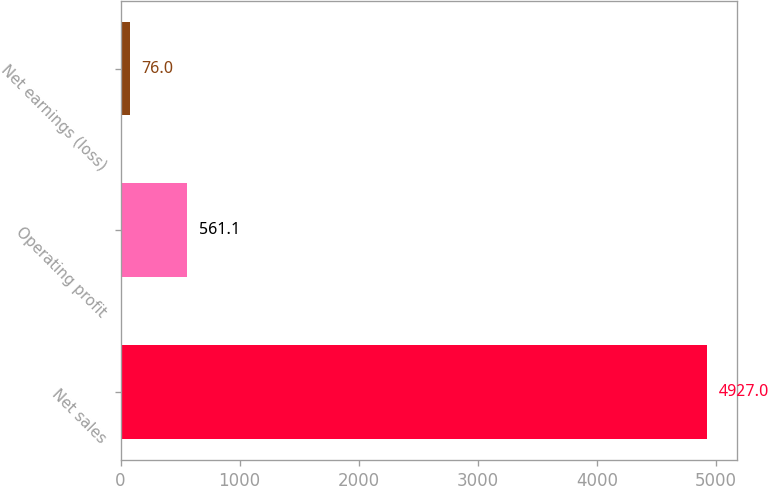Convert chart. <chart><loc_0><loc_0><loc_500><loc_500><bar_chart><fcel>Net sales<fcel>Operating profit<fcel>Net earnings (loss)<nl><fcel>4927<fcel>561.1<fcel>76<nl></chart> 